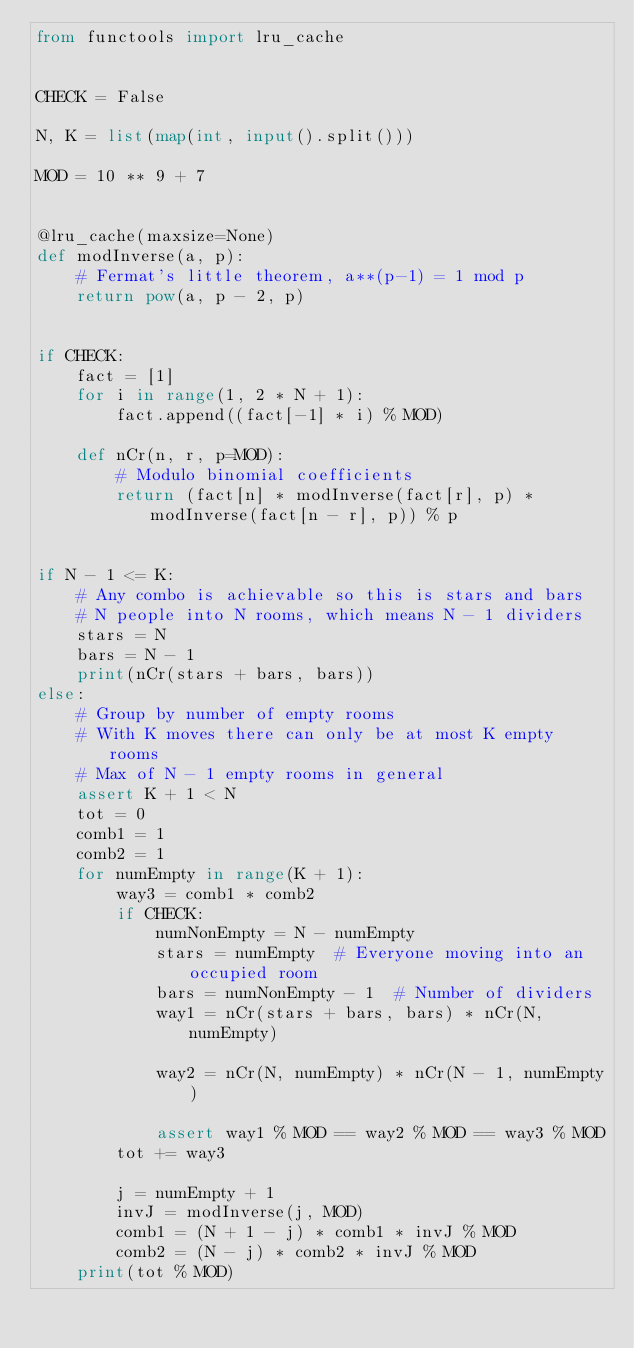<code> <loc_0><loc_0><loc_500><loc_500><_Python_>from functools import lru_cache


CHECK = False

N, K = list(map(int, input().split()))

MOD = 10 ** 9 + 7


@lru_cache(maxsize=None)
def modInverse(a, p):
    # Fermat's little theorem, a**(p-1) = 1 mod p
    return pow(a, p - 2, p)


if CHECK:
    fact = [1]
    for i in range(1, 2 * N + 1):
        fact.append((fact[-1] * i) % MOD)

    def nCr(n, r, p=MOD):
        # Modulo binomial coefficients
        return (fact[n] * modInverse(fact[r], p) * modInverse(fact[n - r], p)) % p


if N - 1 <= K:
    # Any combo is achievable so this is stars and bars
    # N people into N rooms, which means N - 1 dividers
    stars = N
    bars = N - 1
    print(nCr(stars + bars, bars))
else:
    # Group by number of empty rooms
    # With K moves there can only be at most K empty rooms
    # Max of N - 1 empty rooms in general
    assert K + 1 < N
    tot = 0
    comb1 = 1
    comb2 = 1
    for numEmpty in range(K + 1):
        way3 = comb1 * comb2
        if CHECK:
            numNonEmpty = N - numEmpty
            stars = numEmpty  # Everyone moving into an occupied room
            bars = numNonEmpty - 1  # Number of dividers
            way1 = nCr(stars + bars, bars) * nCr(N, numEmpty)

            way2 = nCr(N, numEmpty) * nCr(N - 1, numEmpty)

            assert way1 % MOD == way2 % MOD == way3 % MOD
        tot += way3

        j = numEmpty + 1
        invJ = modInverse(j, MOD)
        comb1 = (N + 1 - j) * comb1 * invJ % MOD
        comb2 = (N - j) * comb2 * invJ % MOD
    print(tot % MOD)
</code> 